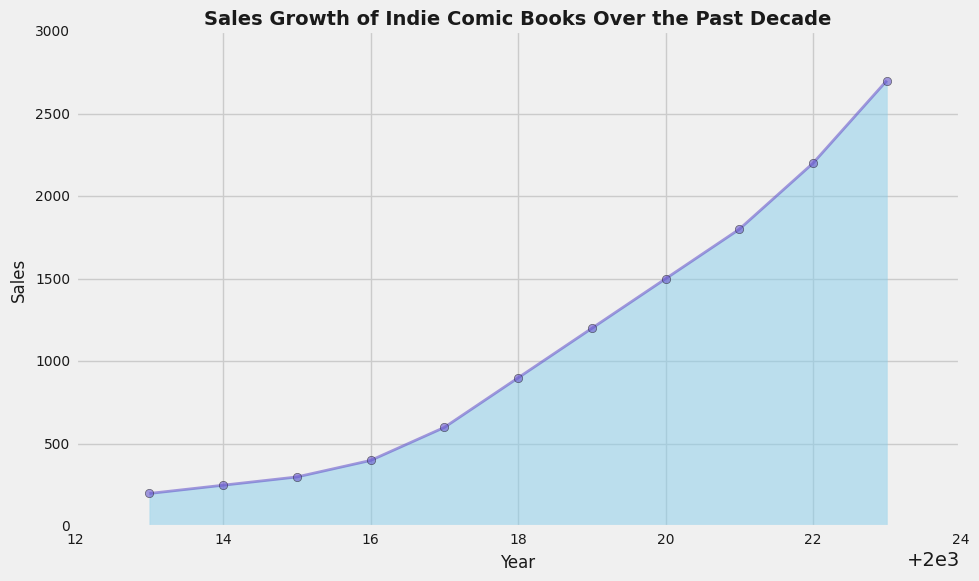What is the sales figure in the year 2015? To find the sales figure for 2015, locate the year 2015 on the x-axis and read the corresponding value on the y-axis.
Answer: 300 From which year did the sales of indie comic books start to increase more rapidly? Observe the plot for points where the sales line slope becomes steeper. The significant increase starts from 2017 onwards.
Answer: 2017 What is the difference in sales between the years 2018 and 2020? Locate the sales value for 2018 (900) and for 2020 (1500). Subtract the sales value of 2018 from the sales value of 2020: 1500 - 900 = 600.
Answer: 600 What are the sales values for the first and the last years in the dataset, and what is the percent increase over this period? Sales values for 2013 and 2023 are 200 and 2700 respectively. Percent increase is calculated by ((2700 - 200) / 200) * 100%.
Answer: 1250% During what years did sales first exceed 1000? Examine the y-axis to find the point where the sales value exceeds 1000. Sales first exceed 1000 in 2019.
Answer: 2019 Which year shows the largest single-year jump in sales? Compare the increase in sales between consecutive years. The largest jump is from 2017 to 2018, where sales increased by 300 (600 to 900).
Answer: 2018 Describe the color and style of the area chart used to show sales growth. The area chart is filled with a sky blue color and has an alpha transparency of 0.5. The line plot is in a Slateblue color and is solid with circular markers.
Answer: Sky blue area with Slateblue line and markers How much did the sales increase from 2016 to 2022? Locate sales value for 2016 (400) and for 2022 (2200). Subtract sales value of 2016 from sales value of 2022: 2200 - 400 = 1800.
Answer: 1800 What is the average sales from 2020 to 2023? Sum the sales values from 2020 to 2023 (1500 + 1800 + 2200 + 2700) and then divide by the number of years (4). The sum is 8200, so the average is 8200/4.
Answer: 2050 